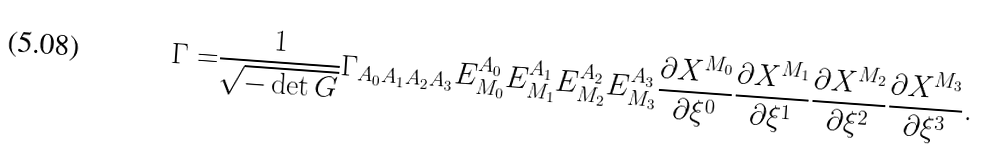Convert formula to latex. <formula><loc_0><loc_0><loc_500><loc_500>\Gamma = & \frac { 1 } { \sqrt { - \det G } } \Gamma _ { A _ { 0 } A _ { 1 } A _ { 2 } A _ { 3 } } E ^ { A _ { 0 } } _ { M _ { 0 } } E ^ { A _ { 1 } } _ { M _ { 1 } } E ^ { A _ { 2 } } _ { M _ { 2 } } E ^ { A _ { 3 } } _ { M _ { 3 } } \frac { \partial X ^ { M _ { 0 } } } { \partial \xi ^ { 0 } } \frac { \partial X ^ { M _ { 1 } } } { \partial \xi ^ { 1 } } \frac { \partial X ^ { M _ { 2 } } } { \partial \xi ^ { 2 } } \frac { \partial X ^ { M _ { 3 } } } { \partial \xi ^ { 3 } } .</formula> 